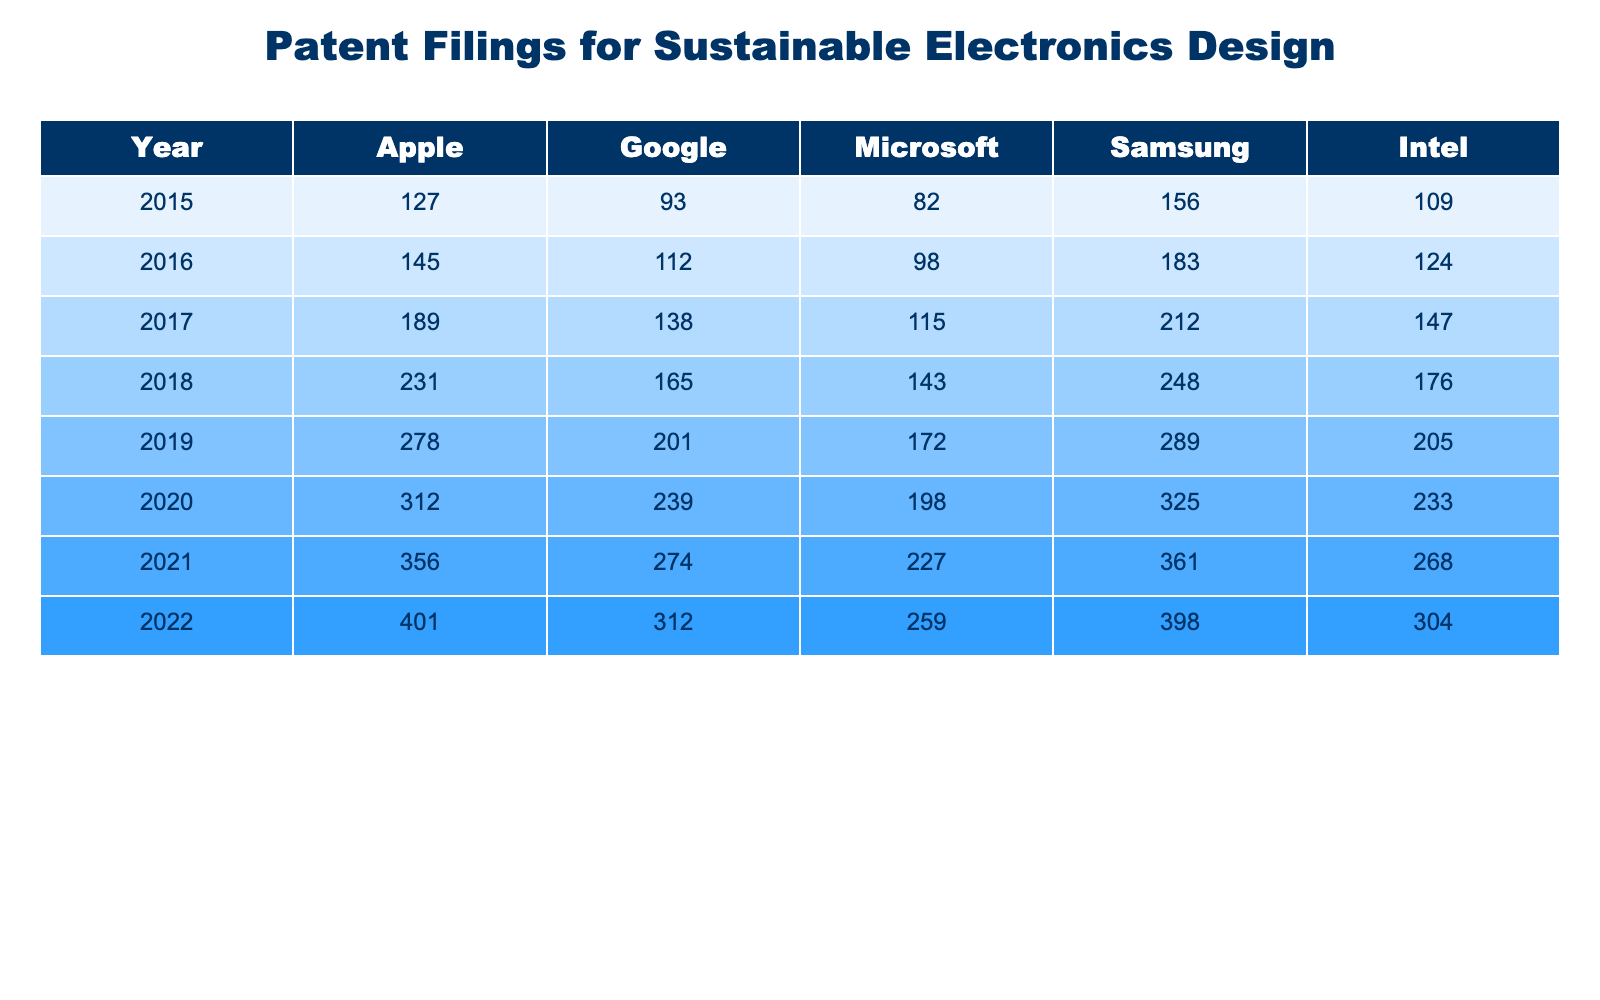What year had the highest patent filings by Apple? Looking at the table, the highest patent filings by Apple occurred in 2022, with a total of 401 filings.
Answer: 2022 What is the total number of patent filings for Samsung from 2015 to 2022? To find the total patent filings for Samsung, we sum the values from each year: 156 + 183 + 212 + 248 + 289 + 325 + 361 + 398 = 1872.
Answer: 1872 In which year did Intel file the least number of patents? The table indicates that Intel's least number of patent filings was in 2015 with 109 patents.
Answer: 2015 Which company had patent filings that grew the most from 2015 to 2022? Comparing the growth from 2015 to 2022, Apple filed 274 more patents (401 - 127), while Google filed 219 more (312 - 93). Therefore, Apple had the highest growth in filings.
Answer: Apple What is the average number of patent filings per year for Microsoft? To find the average for Microsoft, we add the yearly filings (82 + 98 + 115 + 143 + 172 + 198 + 227 + 259 = 1294) and divide by 8 (the number of years), resulting in 162.25.
Answer: 162.25 Did any company consistently file more patents than Intel each year from 2015 to 2022? Since every year listed shows that companies like Apple, Google, Microsoft, and Samsung had more filings than Intel, the answer is yes.
Answer: Yes How many more patents did Samsung file in 2022 compared to 2016? The table shows that Samsung filed 398 patents in 2022 and 183 in 2016, resulting in a difference of 215 (398 - 183).
Answer: 215 What was the percentage increase in patent filings for Google from 2015 to 2022? First, we identify the filings for Google: 93 in 2015 and 312 in 2022. The increase is 219 (312 - 93). The percentage increase is then calculated by (219 / 93) * 100 = 235.48%.
Answer: 235.48% Which company had the smallest increase in patent filings from 2015 to 2022? By comparing the increases: Apple (274), Google (219), Microsoft (145), Samsung (242), Intel (195), we see that Microsoft had the smallest increase with 145.
Answer: Microsoft How many total patents were filed by all companies in 2019? We sum the filings for all companies in 2019: 278 (Apple) + 201 (Google) + 172 (Microsoft) + 289 (Samsung) + 205 (Intel) = 1145 total patents.
Answer: 1145 